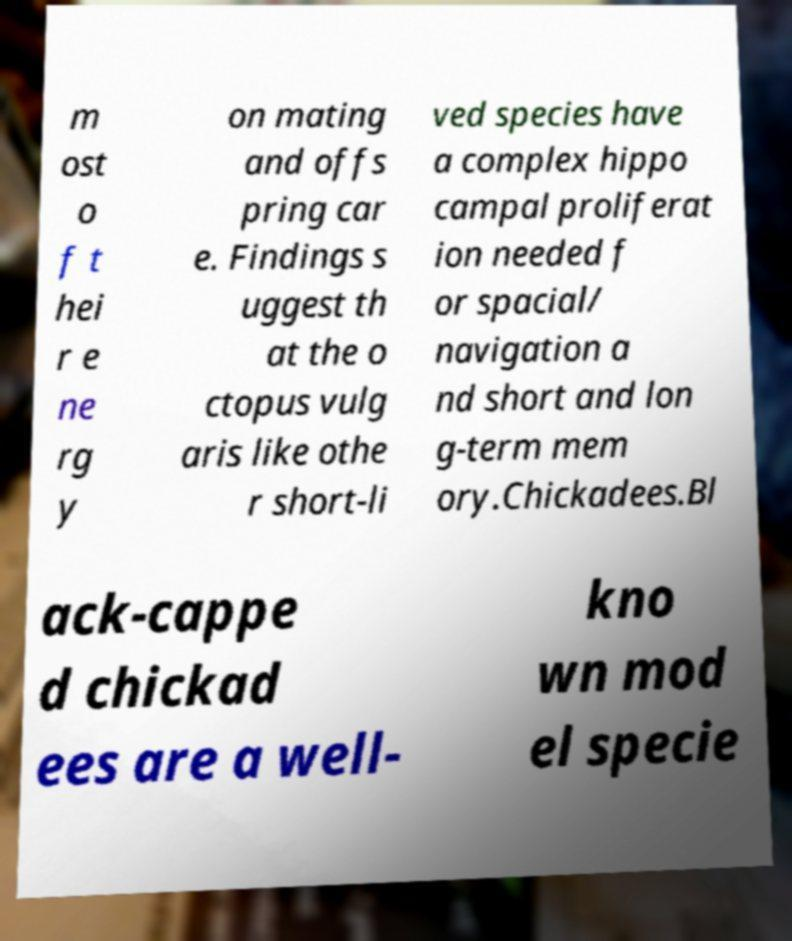Can you read and provide the text displayed in the image?This photo seems to have some interesting text. Can you extract and type it out for me? m ost o f t hei r e ne rg y on mating and offs pring car e. Findings s uggest th at the o ctopus vulg aris like othe r short-li ved species have a complex hippo campal proliferat ion needed f or spacial/ navigation a nd short and lon g-term mem ory.Chickadees.Bl ack-cappe d chickad ees are a well- kno wn mod el specie 